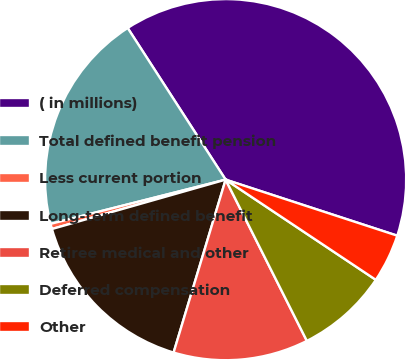Convert chart. <chart><loc_0><loc_0><loc_500><loc_500><pie_chart><fcel>( in millions)<fcel>Total defined benefit pension<fcel>Less current portion<fcel>Long-term defined benefit<fcel>Retiree medical and other<fcel>Deferred compensation<fcel>Other<nl><fcel>39.15%<fcel>19.81%<fcel>0.47%<fcel>15.94%<fcel>12.08%<fcel>8.21%<fcel>4.34%<nl></chart> 